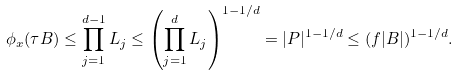<formula> <loc_0><loc_0><loc_500><loc_500>\phi _ { x } ( \tau B ) \leq \prod _ { j = 1 } ^ { d - 1 } L _ { j } \leq \left ( \prod _ { j = 1 } ^ { d } L _ { j } \right ) ^ { 1 - 1 / d } = | P | ^ { 1 - 1 / d } \leq ( f | B | ) ^ { 1 - 1 / d } .</formula> 